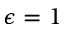<formula> <loc_0><loc_0><loc_500><loc_500>\epsilon = 1</formula> 